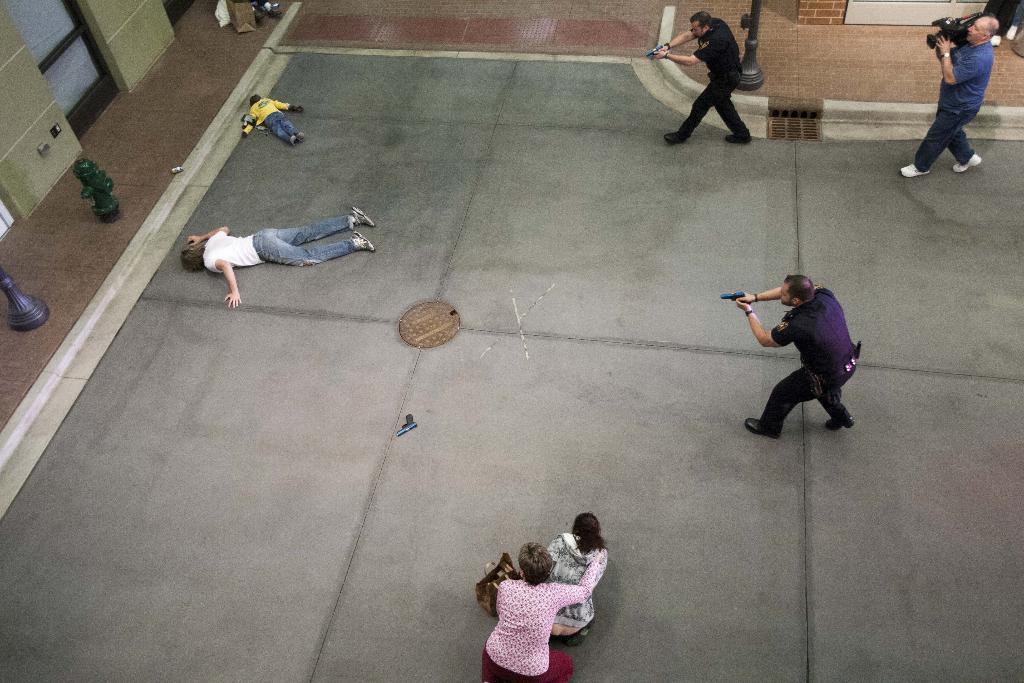How would you summarize this image in a sentence or two? In this picture we can see three men are walking, a man on the right side is holding a camera, two men in the middle are holding guns, on the left side there are two persons laying, we can see a water hydrant and a wall on the left side, at the bottom we can see two more persons. 